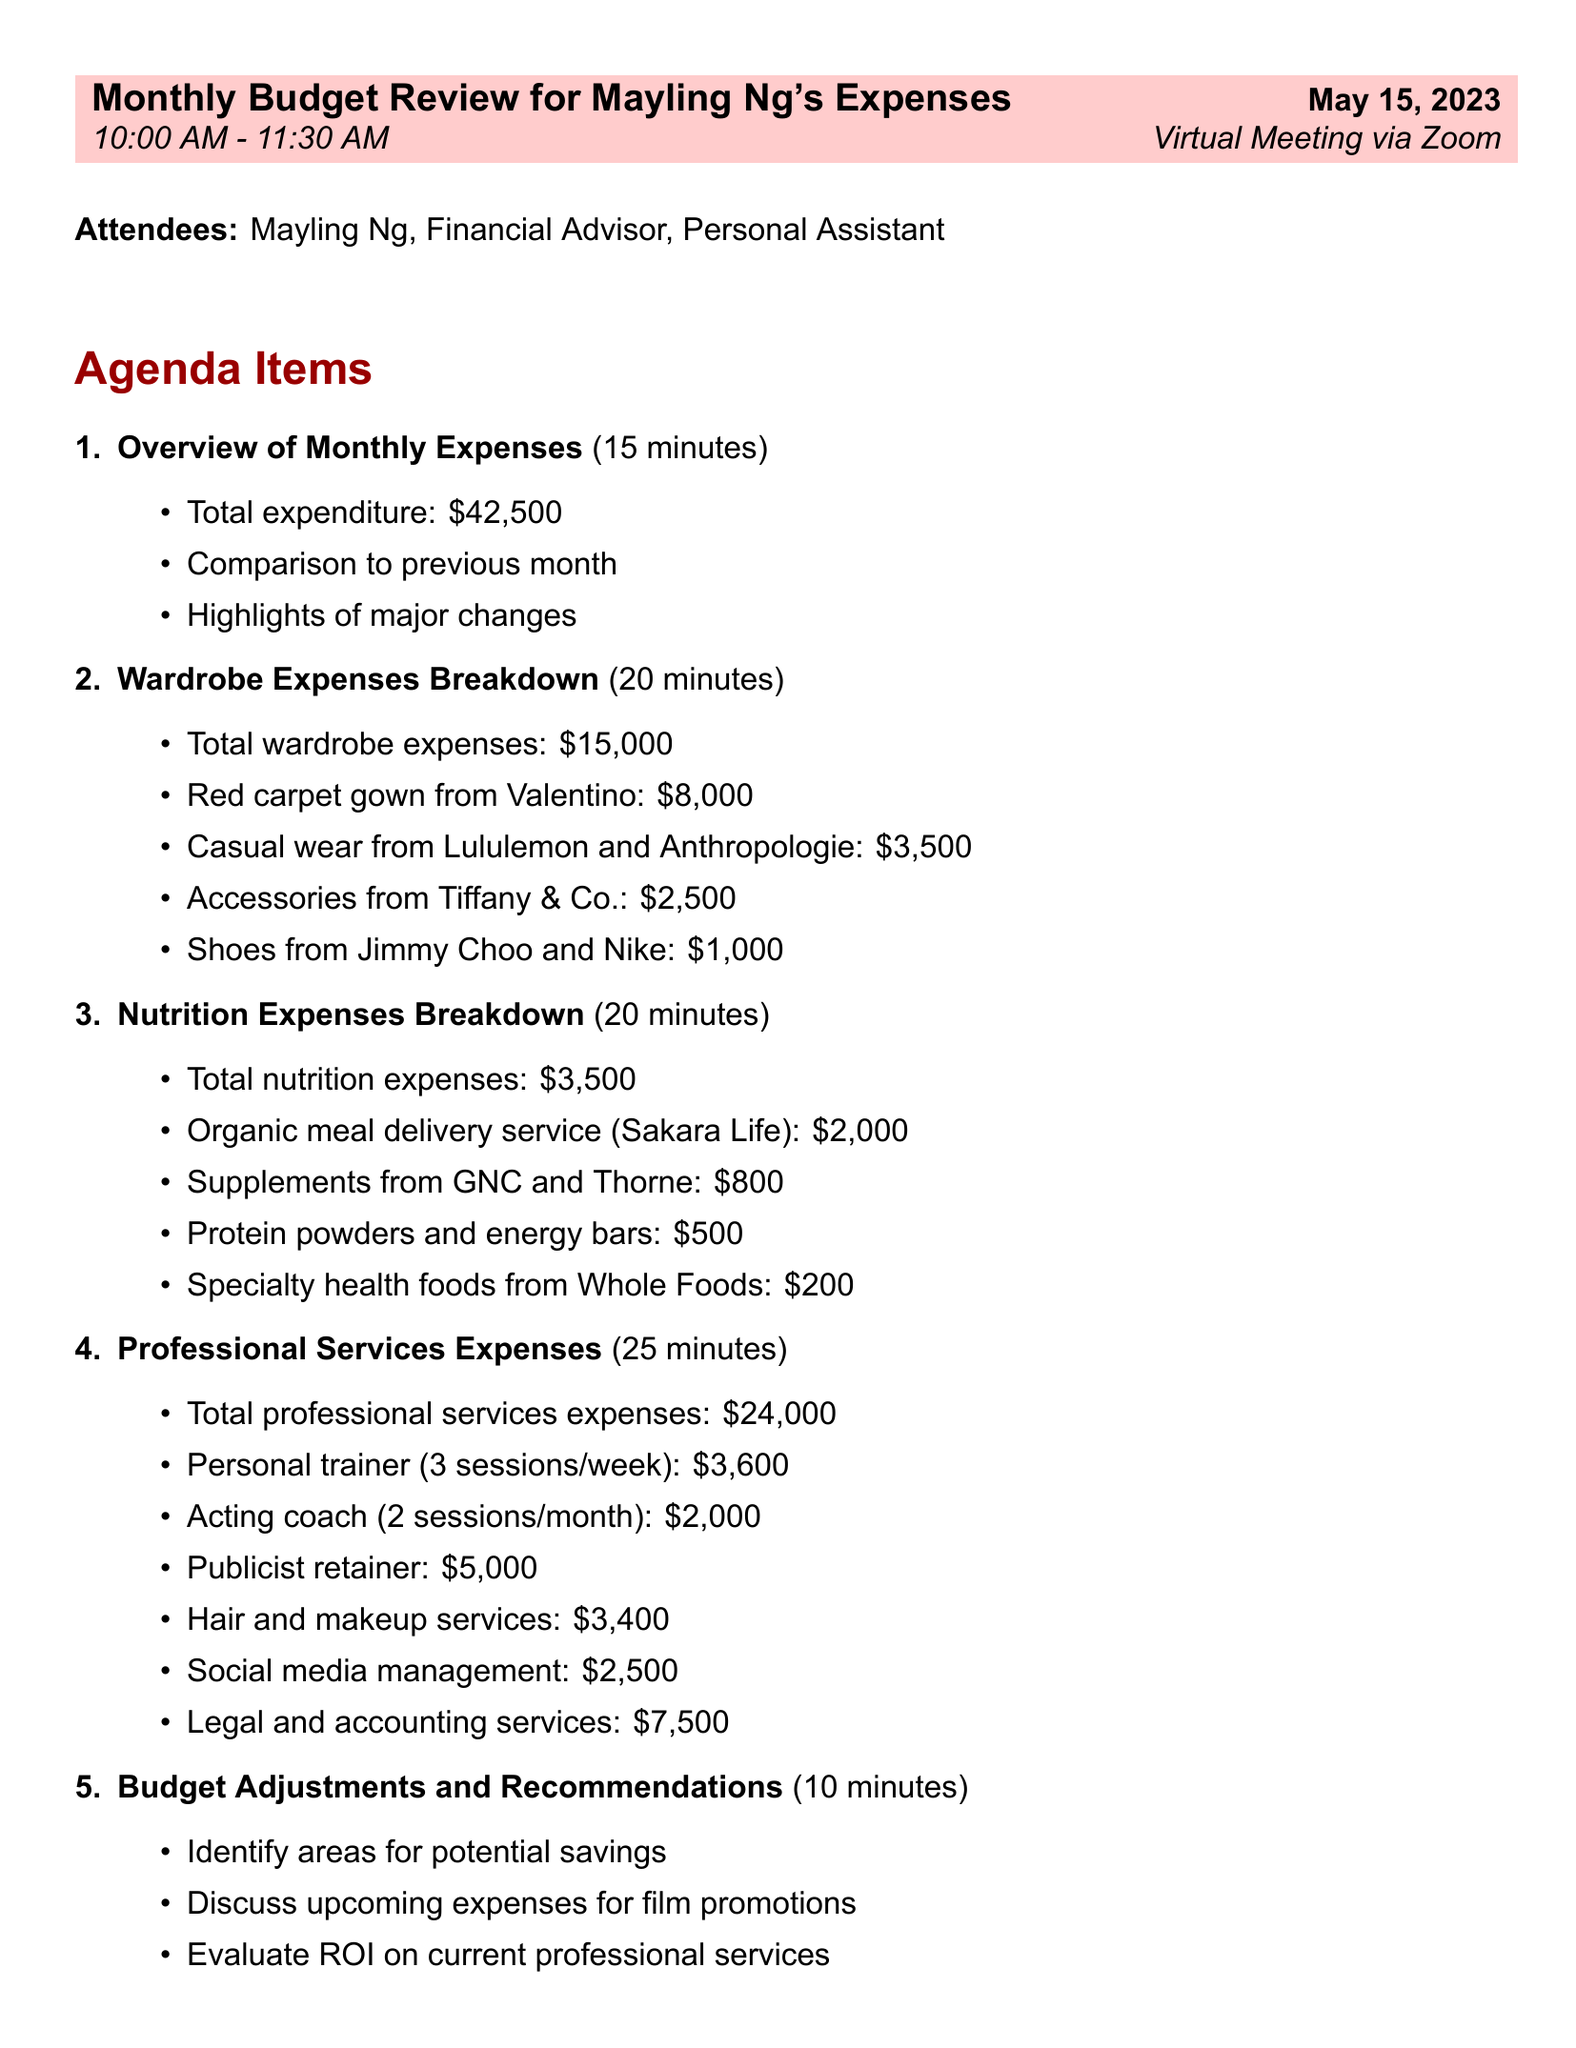What is the date of the budget review meeting? The date is explicitly mentioned in the agenda as "May 15, 2023."
Answer: May 15, 2023 Who will be attending the meeting? The attendees are listed in the document, specifying their roles.
Answer: Mayling Ng, Financial Advisor, Personal Assistant What is the total wardrobe expense? It is directly stated in the agenda item's details as the total amount for wardrobe expenses.
Answer: $15,000 How much is allocated for nutrition expenses? The total nutrition expenses are clearly presented in the document.
Answer: $3,500 What service has the highest expenditure in professional services? By comparing the listed professional services, the publicist retainer shows the highest cost.
Answer: Publicist retainer What is the total expenditure for the month? The total expenditure is provided in the document as part of the overview.
Answer: $42,500 What are the action items relevant to professional services? The document lists specific actions related to professional services, focusing on contracts.
Answer: Review contracts for professional services to ensure best value What time is the budget review meeting scheduled to start? The time is specified in the meeting details provided in the document.
Answer: 10:00 AM How long is the agenda item for budget adjustments scheduled? The duration is mentioned under the specific agenda item.
Answer: 10 minutes 